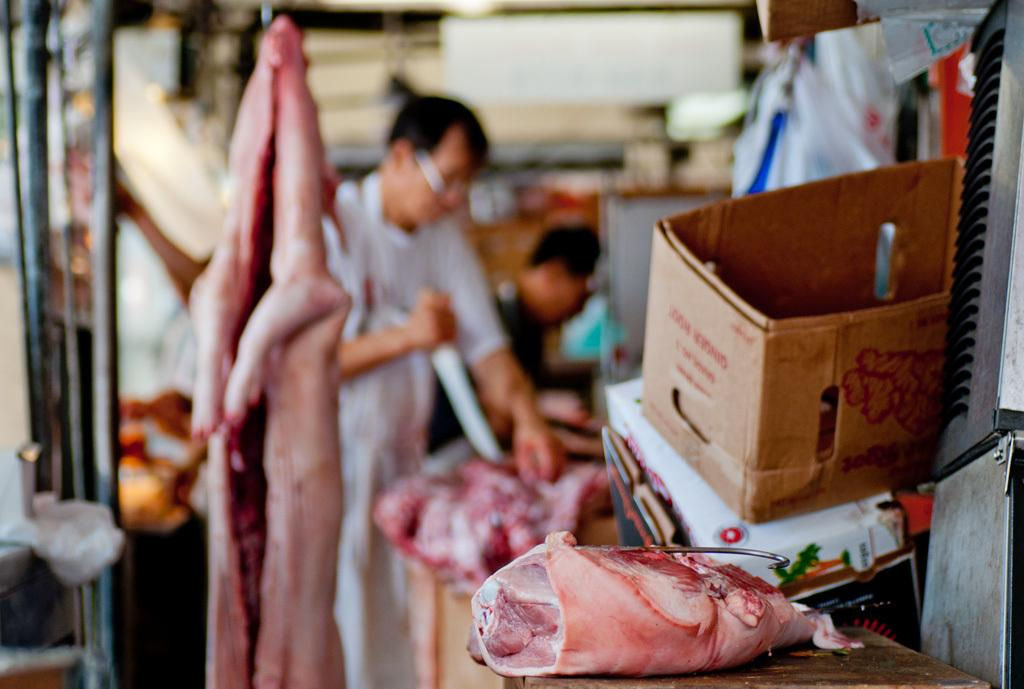What type of food is present in the image? There is meat in the image. What object is present near the meat? There is a cardboard box in the image. What can be seen in the distance of the image? There are people and objects visible in the background of the image. What is the primary piece of furniture in the image? There is a table at the bottom of the image. What type of bun is used to hold the meat in the image? There is no bun present in the image; it only shows meat and a cardboard box. What is the relation between the people in the background of the image? The image does not provide enough information to determine the relationship between the people in the background. 